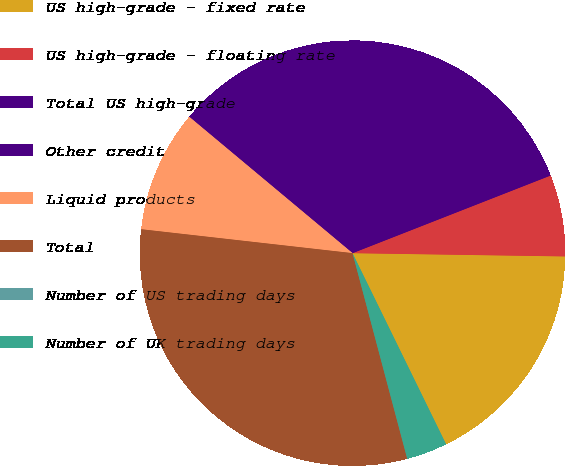<chart> <loc_0><loc_0><loc_500><loc_500><pie_chart><fcel>US high-grade - fixed rate<fcel>US high-grade - floating rate<fcel>Total US high-grade<fcel>Other credit<fcel>Liquid products<fcel>Total<fcel>Number of US trading days<fcel>Number of UK trading days<nl><fcel>17.51%<fcel>6.19%<fcel>20.6%<fcel>12.38%<fcel>9.28%<fcel>30.93%<fcel>0.01%<fcel>3.1%<nl></chart> 